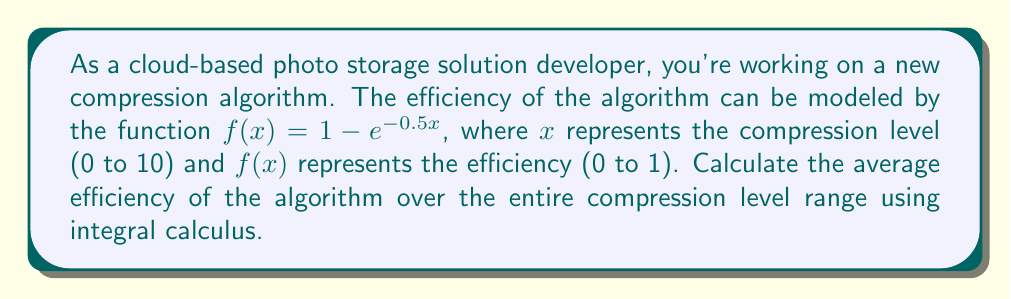Give your solution to this math problem. To solve this problem, we need to follow these steps:

1) The average value of a function $f(x)$ over an interval $[a,b]$ is given by:

   $$\text{Average} = \frac{1}{b-a} \int_{a}^{b} f(x) dx$$

2) In this case, $a=0$, $b=10$, and $f(x) = 1 - e^{-0.5x}$. So we need to calculate:

   $$\text{Average} = \frac{1}{10-0} \int_{0}^{10} (1 - e^{-0.5x}) dx$$

3) Simplify:

   $$\text{Average} = \frac{1}{10} \int_{0}^{10} (1 - e^{-0.5x}) dx$$

4) Integrate:

   $$\begin{align}
   \text{Average} &= \frac{1}{10} \left[x - (-2)e^{-0.5x}\right]_{0}^{10} \\
   &= \frac{1}{10} \left[(10 - (-2)e^{-5}) - (0 - (-2)e^{0})\right] \\
   &= \frac{1}{10} \left[10 + 2e^{-5} - 2\right] \\
   &= \frac{1}{10} \left[8 + 2e^{-5}\right] \\
   &= 0.8 + 0.2e^{-5}
   \end{align}$$

5) Evaluate $e^{-5}$ (approximately 0.00674):

   $$\text{Average} \approx 0.8 + 0.2(0.00674) \approx 0.80135$$
Answer: The average efficiency of the compression algorithm over the range of compression levels is approximately 0.80135 or about 80.14%. 